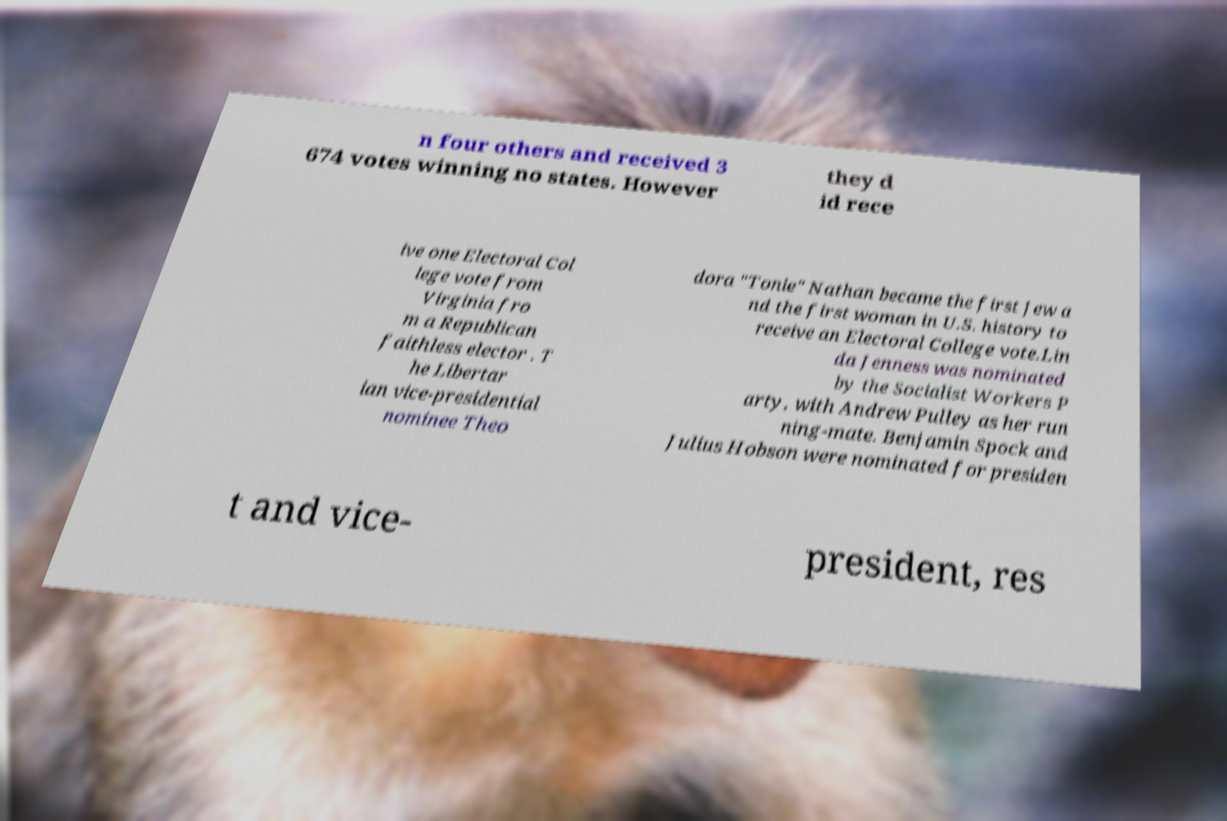Could you extract and type out the text from this image? n four others and received 3 674 votes winning no states. However they d id rece ive one Electoral Col lege vote from Virginia fro m a Republican faithless elector . T he Libertar ian vice-presidential nominee Theo dora "Tonie" Nathan became the first Jew a nd the first woman in U.S. history to receive an Electoral College vote.Lin da Jenness was nominated by the Socialist Workers P arty, with Andrew Pulley as her run ning-mate. Benjamin Spock and Julius Hobson were nominated for presiden t and vice- president, res 